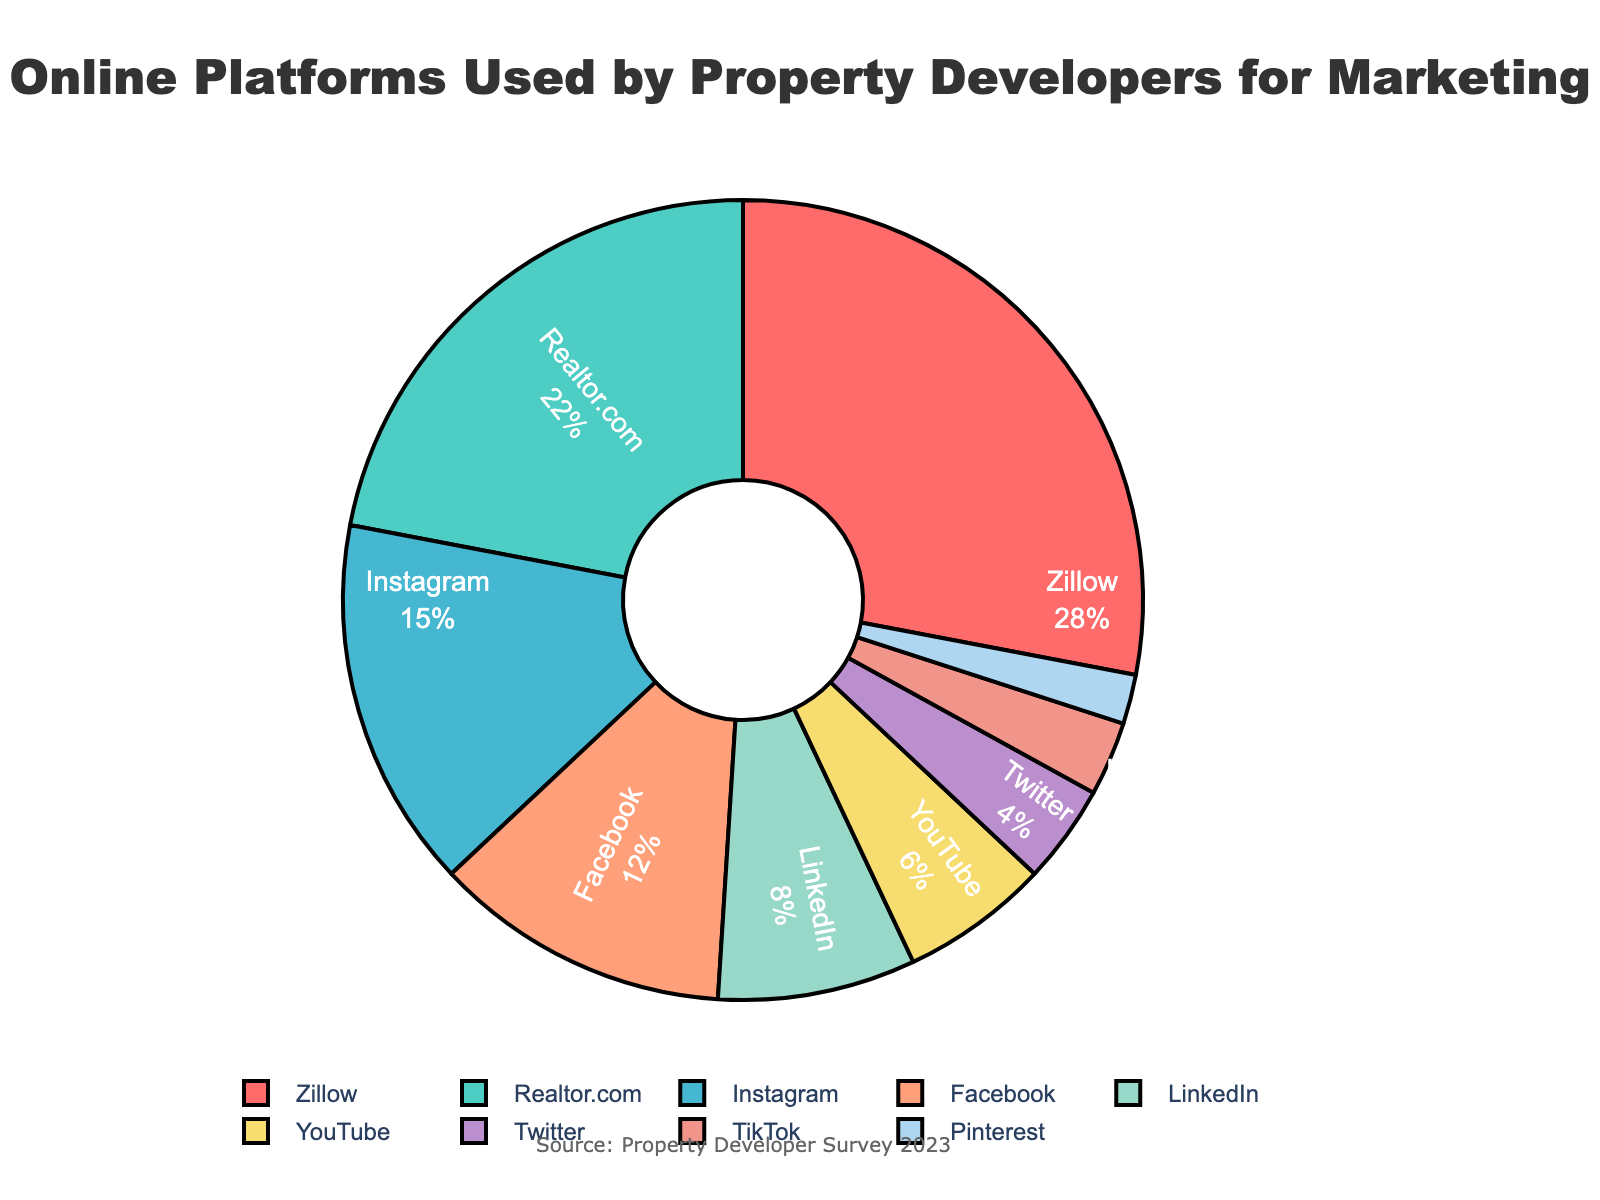Which platform has the highest percentage of usage? By looking at the chart, we can see that Zillow has the largest portion of the pie chart with a percentage marked as 28%.
Answer: Zillow How much more popular is Instagram compared to TikTok? Looking at the percentages given in the chart, Instagram has a 15% usage rate, and TikTok has a 3% usage rate. So, Instagram is 15% - 3% = 12% more popular.
Answer: 12% What is the combined percentage of Facebook, LinkedIn, and Twitter? According to the pie chart, Facebook has 12%, LinkedIn has 8%, and Twitter has 4%. Adding these gives us 12% + 8% + 4% = 24%.
Answer: 24% Which platform is used less than YouTube but more than Pinterest? Pinterest has a 2% usage rate, and YouTube has 6%. Twitter falls in this range with a 4% usage rate.
Answer: Twitter Which color represents Realtor.com on the chart? Referring to the colors used in the pie chart, Realtor.com is assigned the second portion which is represented in green.
Answer: Green How much total percentage do all the platforms occupy together except for Zillow and Realtor.com? Excluding Zillow (28%) and Realtor.com (22%), we sum up the rest: Instagram (15%), Facebook (12%), LinkedIn (8%), YouTube (6%), Twitter (4%), TikTok (3%), and Pinterest (2%). The total percentage is 15% + 12% + 8% + 6% + 4% + 3% + 2% = 50%.
Answer: 50% Which platform's portion is visually closest in size to LinkedIn's? By observing the chart, LinkedIn has 8%. The platform with a visually similar portion is YouTube with 6%, given the small difference.
Answer: YouTube Is the percentage usage of Facebook higher or lower than the average usage of all platforms? The average usage of all platforms is calculated by summing all percentages and dividing by the number of platforms: (28% + 22% + 15% + 12% + 8% + 6% + 4% + 3% + 2%) / 9 = 100% / 9 ≈ 11.11%. Facebook's usage is 12%, which is higher than the average.
Answer: Higher What is the total percentage of platforms that have a usage rate below 10%? Summing the percentages of LinkedIn (8%), YouTube (6%), Twitter (4%), TikTok (3%), and Pinterest (2%) gives us 8% + 6% + 4% + 3% + 2% = 23%.
Answer: 23% 